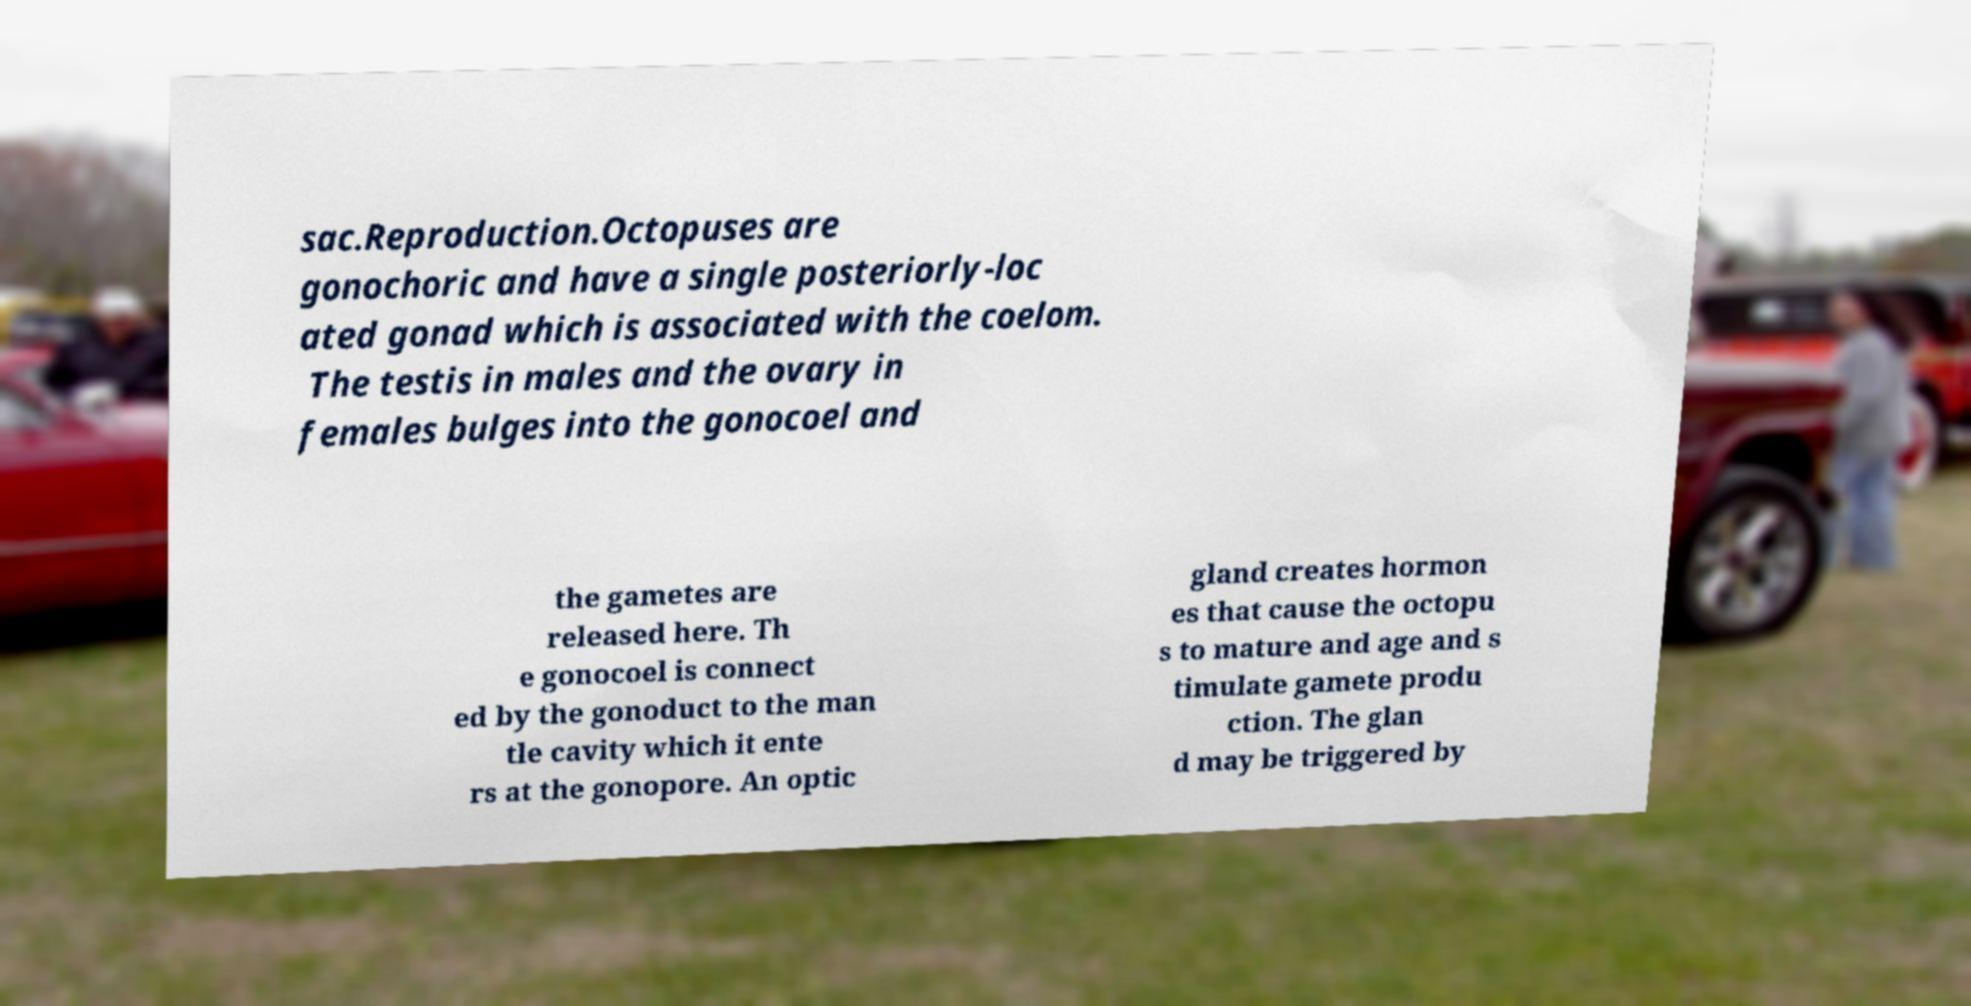For documentation purposes, I need the text within this image transcribed. Could you provide that? sac.Reproduction.Octopuses are gonochoric and have a single posteriorly-loc ated gonad which is associated with the coelom. The testis in males and the ovary in females bulges into the gonocoel and the gametes are released here. Th e gonocoel is connect ed by the gonoduct to the man tle cavity which it ente rs at the gonopore. An optic gland creates hormon es that cause the octopu s to mature and age and s timulate gamete produ ction. The glan d may be triggered by 